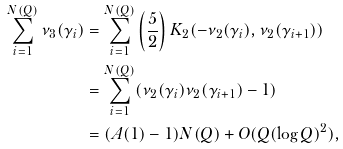<formula> <loc_0><loc_0><loc_500><loc_500>\sum _ { i = 1 } ^ { N ( Q ) } \nu _ { 3 } ( \gamma _ { i } ) & = \sum _ { i = 1 } ^ { N ( Q ) } \left ( \frac { 5 } { 2 } \right ) K _ { 2 } ( - \nu _ { 2 } ( \gamma _ { i } ) , \nu _ { 2 } ( \gamma _ { i + 1 } ) ) \\ & = \sum _ { i = 1 } ^ { N ( Q ) } ( \nu _ { 2 } ( \gamma _ { i } ) \nu _ { 2 } ( \gamma _ { i + 1 } ) - 1 ) \\ & = ( A ( 1 ) - 1 ) N ( Q ) + O ( Q ( \log Q ) ^ { 2 } ) ,</formula> 